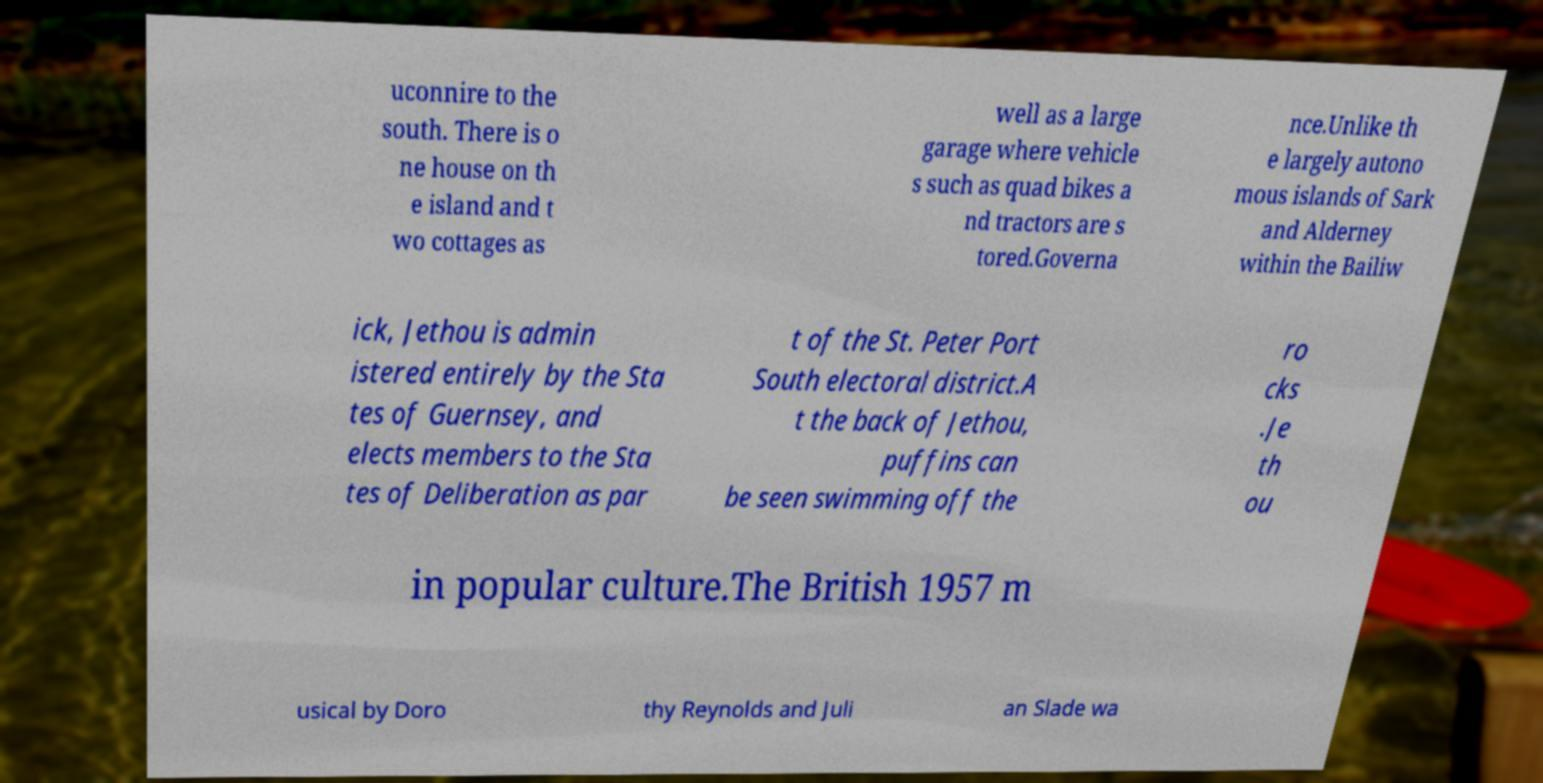Can you read and provide the text displayed in the image?This photo seems to have some interesting text. Can you extract and type it out for me? uconnire to the south. There is o ne house on th e island and t wo cottages as well as a large garage where vehicle s such as quad bikes a nd tractors are s tored.Governa nce.Unlike th e largely autono mous islands of Sark and Alderney within the Bailiw ick, Jethou is admin istered entirely by the Sta tes of Guernsey, and elects members to the Sta tes of Deliberation as par t of the St. Peter Port South electoral district.A t the back of Jethou, puffins can be seen swimming off the ro cks .Je th ou in popular culture.The British 1957 m usical by Doro thy Reynolds and Juli an Slade wa 